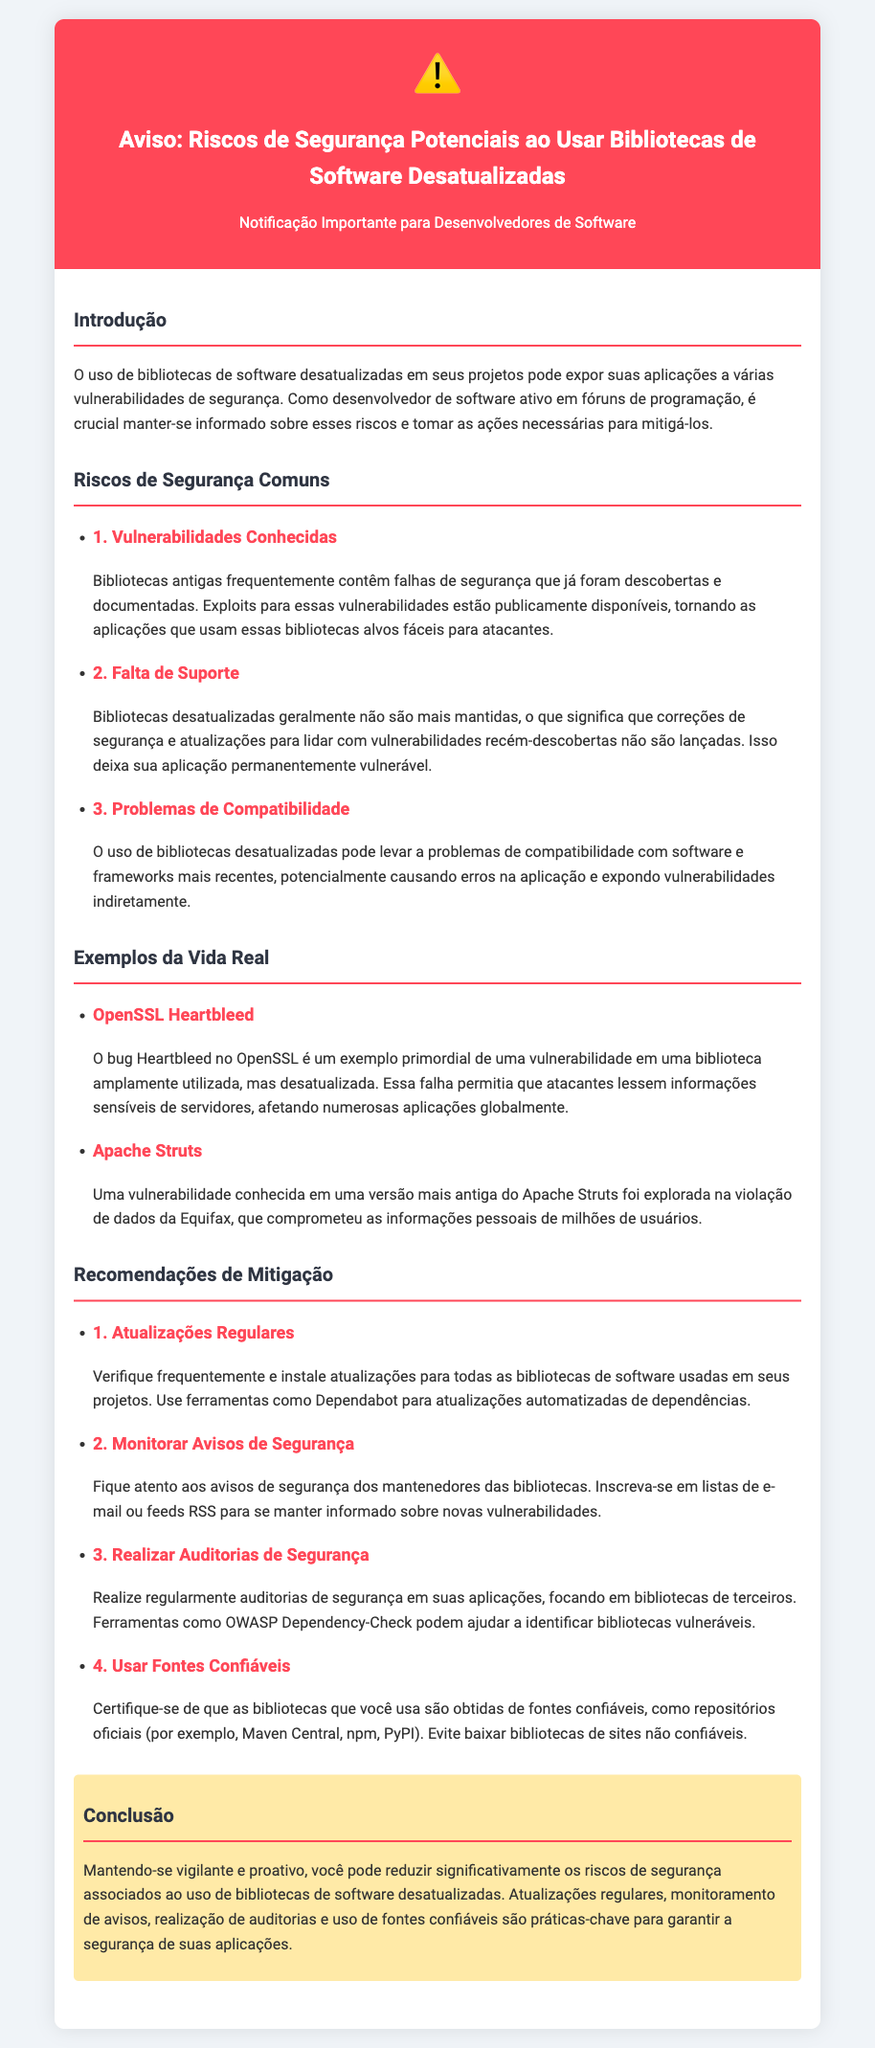Qual é o título do documento? O título do documento é claramente mencionado na seção de cabeçalho.
Answer: Aviso: Riscos de Segurança Potenciais ao Usar Bibliotecas de Software Desatualizadas Quais são duas vulnerabilidades comuns mencionadas? As vulnerabilidades comuns são listadas na seção correspondente, onde cada uma é destacada com um título e explicação.
Answer: Vulnerabilidades Conhecidas, Falta de Suporte Qual exemplo de vulnerabilidade está relacionado ao OpenSSL? O exemplo é fornecido na seção de exemplos da vida real, especificamente associado ao bug no OpenSSL.
Answer: Heartbleed Quantas recomendações de mitigação são apresentadas? O número de recomendações é indicado na seção que lista as soluções para mitigação de riscos.
Answer: Quatro O que faz a ferramenta Dependency-Check? A ferramenta é mencionada como uma maneira de identificar bibliotecas vulneráveis e é descrita nessa seção.
Answer: Identificar bibliotecas vulneráveis Qual é o fundo da seção de aviso? O fundo da seção de aviso é mencionado em relação à cor de fundo como parte do estilo visual.
Answer: Vermelho 